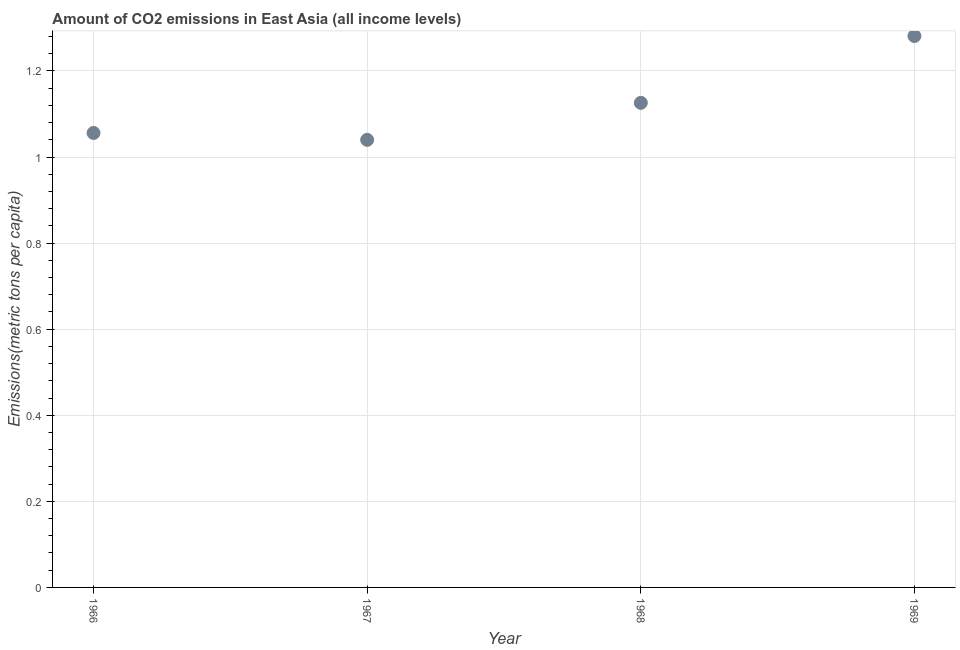What is the amount of co2 emissions in 1967?
Ensure brevity in your answer.  1.04. Across all years, what is the maximum amount of co2 emissions?
Provide a succinct answer. 1.28. Across all years, what is the minimum amount of co2 emissions?
Ensure brevity in your answer.  1.04. In which year was the amount of co2 emissions maximum?
Your answer should be compact. 1969. In which year was the amount of co2 emissions minimum?
Keep it short and to the point. 1967. What is the sum of the amount of co2 emissions?
Provide a succinct answer. 4.5. What is the difference between the amount of co2 emissions in 1967 and 1969?
Provide a succinct answer. -0.24. What is the average amount of co2 emissions per year?
Offer a very short reply. 1.13. What is the median amount of co2 emissions?
Offer a terse response. 1.09. In how many years, is the amount of co2 emissions greater than 0.8400000000000001 metric tons per capita?
Offer a very short reply. 4. What is the ratio of the amount of co2 emissions in 1966 to that in 1967?
Ensure brevity in your answer.  1.02. What is the difference between the highest and the second highest amount of co2 emissions?
Offer a very short reply. 0.16. Is the sum of the amount of co2 emissions in 1967 and 1969 greater than the maximum amount of co2 emissions across all years?
Offer a terse response. Yes. What is the difference between the highest and the lowest amount of co2 emissions?
Keep it short and to the point. 0.24. In how many years, is the amount of co2 emissions greater than the average amount of co2 emissions taken over all years?
Your answer should be compact. 2. Does the amount of co2 emissions monotonically increase over the years?
Offer a terse response. No. How many years are there in the graph?
Offer a terse response. 4. Are the values on the major ticks of Y-axis written in scientific E-notation?
Make the answer very short. No. What is the title of the graph?
Offer a very short reply. Amount of CO2 emissions in East Asia (all income levels). What is the label or title of the X-axis?
Offer a terse response. Year. What is the label or title of the Y-axis?
Your response must be concise. Emissions(metric tons per capita). What is the Emissions(metric tons per capita) in 1966?
Offer a very short reply. 1.06. What is the Emissions(metric tons per capita) in 1967?
Provide a succinct answer. 1.04. What is the Emissions(metric tons per capita) in 1968?
Your answer should be very brief. 1.13. What is the Emissions(metric tons per capita) in 1969?
Ensure brevity in your answer.  1.28. What is the difference between the Emissions(metric tons per capita) in 1966 and 1967?
Your response must be concise. 0.02. What is the difference between the Emissions(metric tons per capita) in 1966 and 1968?
Provide a succinct answer. -0.07. What is the difference between the Emissions(metric tons per capita) in 1966 and 1969?
Your answer should be very brief. -0.23. What is the difference between the Emissions(metric tons per capita) in 1967 and 1968?
Your answer should be compact. -0.09. What is the difference between the Emissions(metric tons per capita) in 1967 and 1969?
Give a very brief answer. -0.24. What is the difference between the Emissions(metric tons per capita) in 1968 and 1969?
Keep it short and to the point. -0.16. What is the ratio of the Emissions(metric tons per capita) in 1966 to that in 1967?
Provide a short and direct response. 1.01. What is the ratio of the Emissions(metric tons per capita) in 1966 to that in 1968?
Offer a terse response. 0.94. What is the ratio of the Emissions(metric tons per capita) in 1966 to that in 1969?
Provide a short and direct response. 0.82. What is the ratio of the Emissions(metric tons per capita) in 1967 to that in 1968?
Your answer should be very brief. 0.92. What is the ratio of the Emissions(metric tons per capita) in 1967 to that in 1969?
Offer a very short reply. 0.81. What is the ratio of the Emissions(metric tons per capita) in 1968 to that in 1969?
Provide a succinct answer. 0.88. 